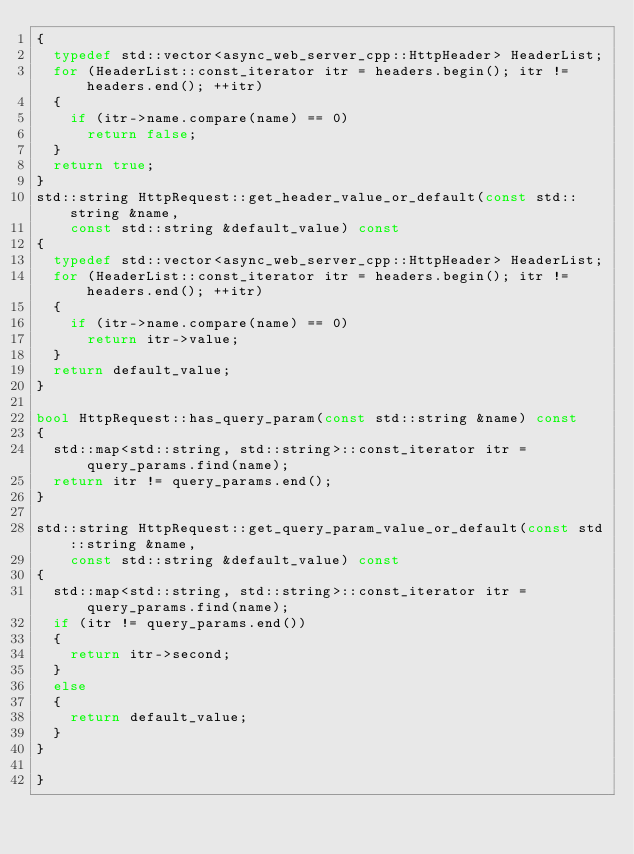Convert code to text. <code><loc_0><loc_0><loc_500><loc_500><_C++_>{
  typedef std::vector<async_web_server_cpp::HttpHeader> HeaderList;
  for (HeaderList::const_iterator itr = headers.begin(); itr != headers.end(); ++itr)
  {
    if (itr->name.compare(name) == 0)
      return false;
  }
  return true;
}
std::string HttpRequest::get_header_value_or_default(const std::string &name,
    const std::string &default_value) const
{
  typedef std::vector<async_web_server_cpp::HttpHeader> HeaderList;
  for (HeaderList::const_iterator itr = headers.begin(); itr != headers.end(); ++itr)
  {
    if (itr->name.compare(name) == 0)
      return itr->value;
  }
  return default_value;
}

bool HttpRequest::has_query_param(const std::string &name) const
{
  std::map<std::string, std::string>::const_iterator itr = query_params.find(name);
  return itr != query_params.end();
}

std::string HttpRequest::get_query_param_value_or_default(const std::string &name,
    const std::string &default_value) const
{
  std::map<std::string, std::string>::const_iterator itr = query_params.find(name);
  if (itr != query_params.end())
  {
    return itr->second;
  }
  else
  {
    return default_value;
  }
}

}
</code> 